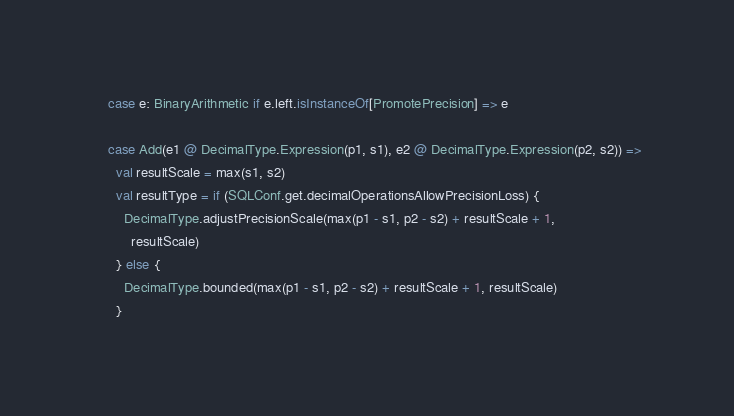<code> <loc_0><loc_0><loc_500><loc_500><_Scala_>    case e: BinaryArithmetic if e.left.isInstanceOf[PromotePrecision] => e

    case Add(e1 @ DecimalType.Expression(p1, s1), e2 @ DecimalType.Expression(p2, s2)) =>
      val resultScale = max(s1, s2)
      val resultType = if (SQLConf.get.decimalOperationsAllowPrecisionLoss) {
        DecimalType.adjustPrecisionScale(max(p1 - s1, p2 - s2) + resultScale + 1,
          resultScale)
      } else {
        DecimalType.bounded(max(p1 - s1, p2 - s2) + resultScale + 1, resultScale)
      }</code> 